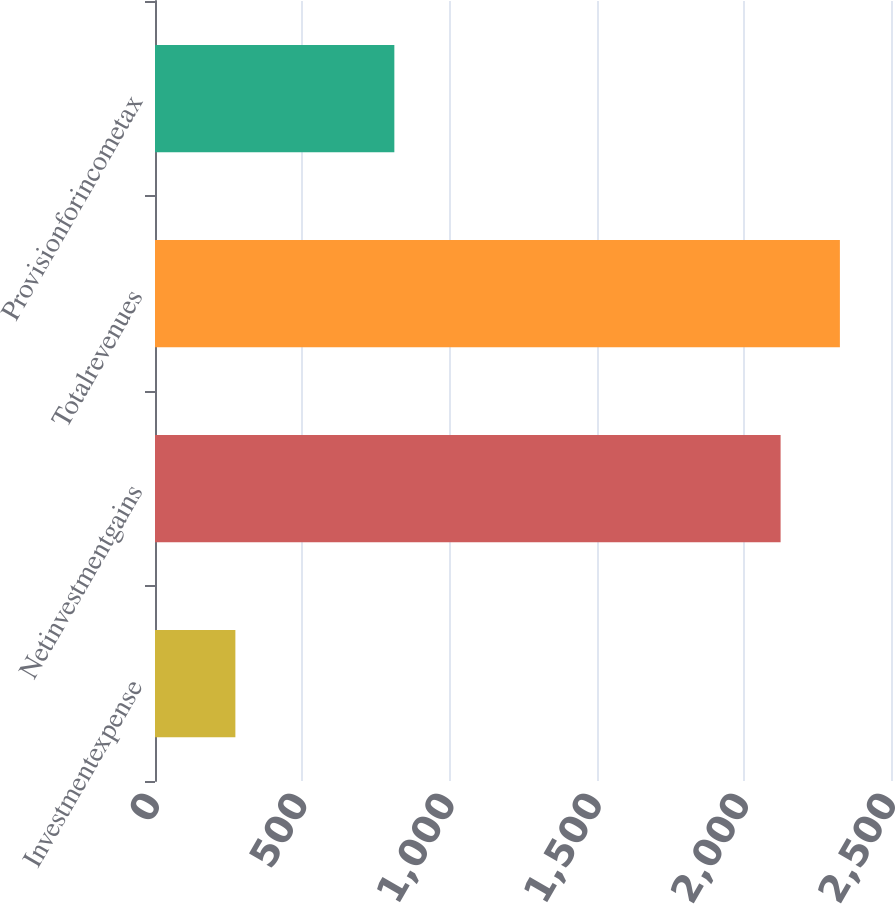Convert chart to OTSL. <chart><loc_0><loc_0><loc_500><loc_500><bar_chart><fcel>Investmentexpense<fcel>Netinvestmentgains<fcel>Totalrevenues<fcel>Provisionforincometax<nl><fcel>273<fcel>2125<fcel>2326.4<fcel>813<nl></chart> 